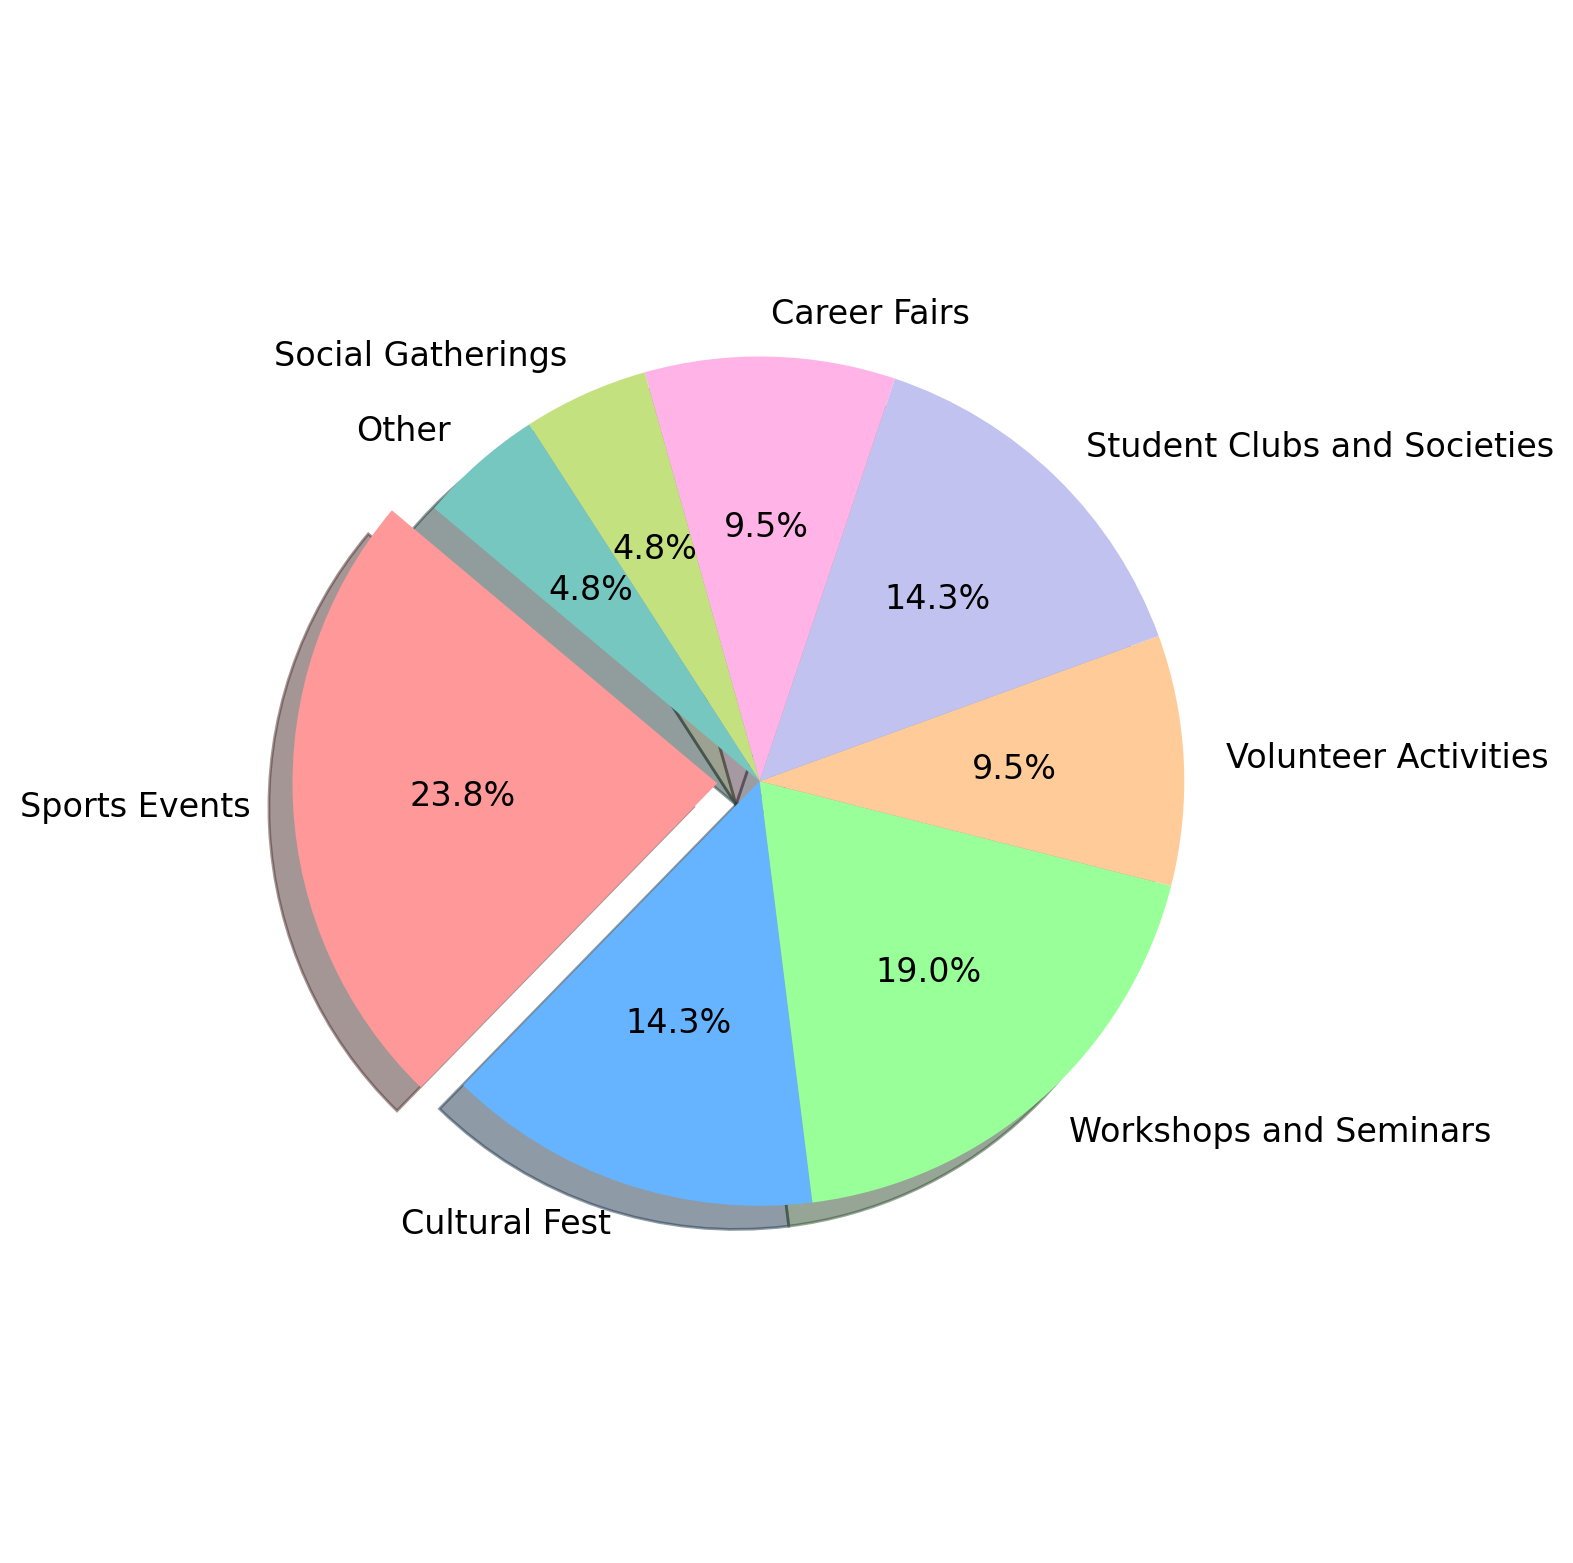What's the most engaged type of campus event? The pie chart shows that Sports Events have the largest percentage of engagement at 25%, which is higher than any other category.
Answer: Sports Events Which type of event has the least engagement? The pie chart indicates that Social Gatherings and Other both have the smallest percentage of engagement at 5%. These slices are visibly the smallest on the chart.
Answer: Social Gatherings and Other How much more engagement do Workshops and Seminars have compared to Career Fairs? Workshops and Seminars have an engagement of 20%, while Career Fairs have 10%. The difference is calculated as 20% - 10% = 10%.
Answer: 10% Are Student Clubs and Societies or Cultural Fest more popular? According to the pie chart, both Student Clubs and Societies and Cultural Fest have the same percentage of engagement, which is 15%.
Answer: They are equal What is the combined engagement percentage for the least popular categories? The least popular categories are Social Gatherings and Other, each with 5% engagement. The combined percentage is 5% + 5% = 10%.
Answer: 10% Which slice in the pie chart is visually emphasized? The slice representing Sports Events is visually emphasized by being separated from the rest of the pie chart.
Answer: Sports Events Are Volunteer Activities more popular than Cultural Fest? According to the pie chart, Volunteer Activities have a 10% engagement, while Cultural Fest has a 15% engagement. Hence, Cultural Fest is more popular than Volunteer Activities.
Answer: No How many event types have 15% engagement each? The pie chart shows two event types each with 15% engagement: Cultural Fest and Student Clubs and Societies.
Answer: 2 What is the difference in engagement between Sports Events and Social Gatherings? Sports Events have an engagement of 25%, and Social Gatherings have 5%. The difference is calculated as 25% - 5% = 20%.
Answer: 20% What percentage of engagement is accounted for by Career Fairs and Volunteer Activities combined? Career Fairs have 10% engagement, and Volunteer Activities also have 10%. Combined, the percentage is 10% + 10% = 20%.
Answer: 20% 